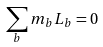<formula> <loc_0><loc_0><loc_500><loc_500>\sum _ { b } m _ { b } L _ { b } = 0</formula> 